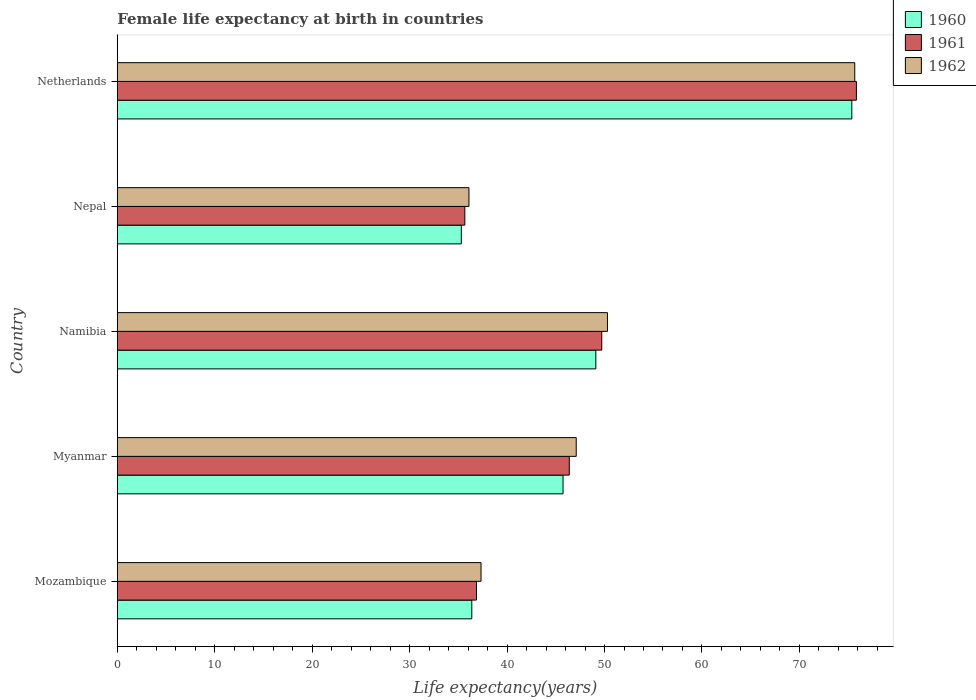How many different coloured bars are there?
Keep it short and to the point. 3. Are the number of bars per tick equal to the number of legend labels?
Keep it short and to the point. Yes. Are the number of bars on each tick of the Y-axis equal?
Give a very brief answer. Yes. How many bars are there on the 5th tick from the top?
Provide a succinct answer. 3. What is the female life expectancy at birth in 1962 in Myanmar?
Your answer should be very brief. 47.1. Across all countries, what is the maximum female life expectancy at birth in 1962?
Give a very brief answer. 75.68. Across all countries, what is the minimum female life expectancy at birth in 1961?
Provide a short and direct response. 35.67. In which country was the female life expectancy at birth in 1960 minimum?
Make the answer very short. Nepal. What is the total female life expectancy at birth in 1962 in the graph?
Your answer should be very brief. 246.5. What is the difference between the female life expectancy at birth in 1962 in Myanmar and that in Nepal?
Make the answer very short. 11.01. What is the difference between the female life expectancy at birth in 1962 in Namibia and the female life expectancy at birth in 1961 in Nepal?
Your response must be concise. 14.64. What is the average female life expectancy at birth in 1960 per country?
Give a very brief answer. 48.38. What is the difference between the female life expectancy at birth in 1961 and female life expectancy at birth in 1962 in Nepal?
Make the answer very short. -0.42. What is the ratio of the female life expectancy at birth in 1962 in Nepal to that in Netherlands?
Provide a short and direct response. 0.48. What is the difference between the highest and the second highest female life expectancy at birth in 1961?
Your response must be concise. 26.13. What is the difference between the highest and the lowest female life expectancy at birth in 1962?
Your answer should be very brief. 39.59. Is the sum of the female life expectancy at birth in 1960 in Myanmar and Nepal greater than the maximum female life expectancy at birth in 1961 across all countries?
Provide a succinct answer. Yes. How many bars are there?
Your answer should be compact. 15. Does the graph contain grids?
Offer a terse response. No. Where does the legend appear in the graph?
Give a very brief answer. Top right. What is the title of the graph?
Provide a succinct answer. Female life expectancy at birth in countries. What is the label or title of the X-axis?
Provide a short and direct response. Life expectancy(years). What is the label or title of the Y-axis?
Provide a succinct answer. Country. What is the Life expectancy(years) in 1960 in Mozambique?
Provide a short and direct response. 36.38. What is the Life expectancy(years) of 1961 in Mozambique?
Ensure brevity in your answer.  36.86. What is the Life expectancy(years) in 1962 in Mozambique?
Your answer should be compact. 37.33. What is the Life expectancy(years) in 1960 in Myanmar?
Ensure brevity in your answer.  45.74. What is the Life expectancy(years) in 1961 in Myanmar?
Keep it short and to the point. 46.38. What is the Life expectancy(years) of 1962 in Myanmar?
Offer a very short reply. 47.1. What is the Life expectancy(years) in 1960 in Namibia?
Offer a very short reply. 49.11. What is the Life expectancy(years) in 1961 in Namibia?
Your response must be concise. 49.72. What is the Life expectancy(years) of 1962 in Namibia?
Offer a very short reply. 50.3. What is the Life expectancy(years) in 1960 in Nepal?
Your answer should be very brief. 35.3. What is the Life expectancy(years) of 1961 in Nepal?
Your response must be concise. 35.67. What is the Life expectancy(years) in 1962 in Nepal?
Offer a very short reply. 36.09. What is the Life expectancy(years) of 1960 in Netherlands?
Make the answer very short. 75.38. What is the Life expectancy(years) in 1961 in Netherlands?
Provide a succinct answer. 75.85. What is the Life expectancy(years) in 1962 in Netherlands?
Offer a terse response. 75.68. Across all countries, what is the maximum Life expectancy(years) of 1960?
Your answer should be compact. 75.38. Across all countries, what is the maximum Life expectancy(years) in 1961?
Ensure brevity in your answer.  75.85. Across all countries, what is the maximum Life expectancy(years) in 1962?
Give a very brief answer. 75.68. Across all countries, what is the minimum Life expectancy(years) of 1960?
Provide a short and direct response. 35.3. Across all countries, what is the minimum Life expectancy(years) in 1961?
Make the answer very short. 35.67. Across all countries, what is the minimum Life expectancy(years) of 1962?
Offer a very short reply. 36.09. What is the total Life expectancy(years) of 1960 in the graph?
Offer a terse response. 241.92. What is the total Life expectancy(years) of 1961 in the graph?
Provide a short and direct response. 244.48. What is the total Life expectancy(years) of 1962 in the graph?
Keep it short and to the point. 246.5. What is the difference between the Life expectancy(years) of 1960 in Mozambique and that in Myanmar?
Offer a terse response. -9.36. What is the difference between the Life expectancy(years) of 1961 in Mozambique and that in Myanmar?
Your answer should be very brief. -9.52. What is the difference between the Life expectancy(years) of 1962 in Mozambique and that in Myanmar?
Provide a short and direct response. -9.77. What is the difference between the Life expectancy(years) in 1960 in Mozambique and that in Namibia?
Your answer should be very brief. -12.73. What is the difference between the Life expectancy(years) of 1961 in Mozambique and that in Namibia?
Offer a very short reply. -12.85. What is the difference between the Life expectancy(years) of 1962 in Mozambique and that in Namibia?
Your answer should be compact. -12.97. What is the difference between the Life expectancy(years) in 1960 in Mozambique and that in Nepal?
Your response must be concise. 1.08. What is the difference between the Life expectancy(years) in 1961 in Mozambique and that in Nepal?
Ensure brevity in your answer.  1.2. What is the difference between the Life expectancy(years) in 1962 in Mozambique and that in Nepal?
Provide a short and direct response. 1.24. What is the difference between the Life expectancy(years) in 1960 in Mozambique and that in Netherlands?
Make the answer very short. -39. What is the difference between the Life expectancy(years) in 1961 in Mozambique and that in Netherlands?
Offer a terse response. -38.99. What is the difference between the Life expectancy(years) of 1962 in Mozambique and that in Netherlands?
Your answer should be compact. -38.35. What is the difference between the Life expectancy(years) in 1960 in Myanmar and that in Namibia?
Ensure brevity in your answer.  -3.37. What is the difference between the Life expectancy(years) of 1961 in Myanmar and that in Namibia?
Offer a very short reply. -3.33. What is the difference between the Life expectancy(years) of 1962 in Myanmar and that in Namibia?
Offer a terse response. -3.21. What is the difference between the Life expectancy(years) of 1960 in Myanmar and that in Nepal?
Give a very brief answer. 10.44. What is the difference between the Life expectancy(years) in 1961 in Myanmar and that in Nepal?
Your response must be concise. 10.72. What is the difference between the Life expectancy(years) in 1962 in Myanmar and that in Nepal?
Keep it short and to the point. 11.01. What is the difference between the Life expectancy(years) of 1960 in Myanmar and that in Netherlands?
Your answer should be compact. -29.64. What is the difference between the Life expectancy(years) in 1961 in Myanmar and that in Netherlands?
Your answer should be compact. -29.47. What is the difference between the Life expectancy(years) in 1962 in Myanmar and that in Netherlands?
Keep it short and to the point. -28.58. What is the difference between the Life expectancy(years) of 1960 in Namibia and that in Nepal?
Make the answer very short. 13.81. What is the difference between the Life expectancy(years) in 1961 in Namibia and that in Nepal?
Give a very brief answer. 14.05. What is the difference between the Life expectancy(years) of 1962 in Namibia and that in Nepal?
Provide a short and direct response. 14.21. What is the difference between the Life expectancy(years) of 1960 in Namibia and that in Netherlands?
Give a very brief answer. -26.27. What is the difference between the Life expectancy(years) in 1961 in Namibia and that in Netherlands?
Offer a terse response. -26.13. What is the difference between the Life expectancy(years) in 1962 in Namibia and that in Netherlands?
Give a very brief answer. -25.38. What is the difference between the Life expectancy(years) of 1960 in Nepal and that in Netherlands?
Keep it short and to the point. -40.08. What is the difference between the Life expectancy(years) in 1961 in Nepal and that in Netherlands?
Your answer should be very brief. -40.18. What is the difference between the Life expectancy(years) of 1962 in Nepal and that in Netherlands?
Offer a terse response. -39.59. What is the difference between the Life expectancy(years) in 1960 in Mozambique and the Life expectancy(years) in 1961 in Myanmar?
Offer a very short reply. -10. What is the difference between the Life expectancy(years) in 1960 in Mozambique and the Life expectancy(years) in 1962 in Myanmar?
Offer a very short reply. -10.72. What is the difference between the Life expectancy(years) of 1961 in Mozambique and the Life expectancy(years) of 1962 in Myanmar?
Your answer should be very brief. -10.23. What is the difference between the Life expectancy(years) in 1960 in Mozambique and the Life expectancy(years) in 1961 in Namibia?
Offer a terse response. -13.34. What is the difference between the Life expectancy(years) in 1960 in Mozambique and the Life expectancy(years) in 1962 in Namibia?
Offer a terse response. -13.92. What is the difference between the Life expectancy(years) of 1961 in Mozambique and the Life expectancy(years) of 1962 in Namibia?
Make the answer very short. -13.44. What is the difference between the Life expectancy(years) in 1960 in Mozambique and the Life expectancy(years) in 1961 in Nepal?
Offer a terse response. 0.71. What is the difference between the Life expectancy(years) of 1960 in Mozambique and the Life expectancy(years) of 1962 in Nepal?
Provide a short and direct response. 0.29. What is the difference between the Life expectancy(years) of 1961 in Mozambique and the Life expectancy(years) of 1962 in Nepal?
Your answer should be compact. 0.78. What is the difference between the Life expectancy(years) of 1960 in Mozambique and the Life expectancy(years) of 1961 in Netherlands?
Your answer should be very brief. -39.47. What is the difference between the Life expectancy(years) in 1960 in Mozambique and the Life expectancy(years) in 1962 in Netherlands?
Offer a terse response. -39.3. What is the difference between the Life expectancy(years) of 1961 in Mozambique and the Life expectancy(years) of 1962 in Netherlands?
Give a very brief answer. -38.82. What is the difference between the Life expectancy(years) in 1960 in Myanmar and the Life expectancy(years) in 1961 in Namibia?
Give a very brief answer. -3.97. What is the difference between the Life expectancy(years) of 1960 in Myanmar and the Life expectancy(years) of 1962 in Namibia?
Ensure brevity in your answer.  -4.56. What is the difference between the Life expectancy(years) of 1961 in Myanmar and the Life expectancy(years) of 1962 in Namibia?
Offer a very short reply. -3.92. What is the difference between the Life expectancy(years) of 1960 in Myanmar and the Life expectancy(years) of 1961 in Nepal?
Your answer should be very brief. 10.08. What is the difference between the Life expectancy(years) in 1960 in Myanmar and the Life expectancy(years) in 1962 in Nepal?
Offer a very short reply. 9.66. What is the difference between the Life expectancy(years) of 1961 in Myanmar and the Life expectancy(years) of 1962 in Nepal?
Ensure brevity in your answer.  10.3. What is the difference between the Life expectancy(years) in 1960 in Myanmar and the Life expectancy(years) in 1961 in Netherlands?
Provide a succinct answer. -30.11. What is the difference between the Life expectancy(years) in 1960 in Myanmar and the Life expectancy(years) in 1962 in Netherlands?
Your response must be concise. -29.94. What is the difference between the Life expectancy(years) in 1961 in Myanmar and the Life expectancy(years) in 1962 in Netherlands?
Your answer should be very brief. -29.3. What is the difference between the Life expectancy(years) in 1960 in Namibia and the Life expectancy(years) in 1961 in Nepal?
Keep it short and to the point. 13.45. What is the difference between the Life expectancy(years) in 1960 in Namibia and the Life expectancy(years) in 1962 in Nepal?
Keep it short and to the point. 13.02. What is the difference between the Life expectancy(years) in 1961 in Namibia and the Life expectancy(years) in 1962 in Nepal?
Make the answer very short. 13.63. What is the difference between the Life expectancy(years) in 1960 in Namibia and the Life expectancy(years) in 1961 in Netherlands?
Provide a succinct answer. -26.74. What is the difference between the Life expectancy(years) in 1960 in Namibia and the Life expectancy(years) in 1962 in Netherlands?
Provide a short and direct response. -26.57. What is the difference between the Life expectancy(years) in 1961 in Namibia and the Life expectancy(years) in 1962 in Netherlands?
Make the answer very short. -25.96. What is the difference between the Life expectancy(years) in 1960 in Nepal and the Life expectancy(years) in 1961 in Netherlands?
Your answer should be very brief. -40.55. What is the difference between the Life expectancy(years) in 1960 in Nepal and the Life expectancy(years) in 1962 in Netherlands?
Keep it short and to the point. -40.38. What is the difference between the Life expectancy(years) of 1961 in Nepal and the Life expectancy(years) of 1962 in Netherlands?
Offer a terse response. -40.01. What is the average Life expectancy(years) of 1960 per country?
Give a very brief answer. 48.38. What is the average Life expectancy(years) in 1961 per country?
Give a very brief answer. 48.9. What is the average Life expectancy(years) in 1962 per country?
Provide a short and direct response. 49.3. What is the difference between the Life expectancy(years) of 1960 and Life expectancy(years) of 1961 in Mozambique?
Ensure brevity in your answer.  -0.48. What is the difference between the Life expectancy(years) of 1960 and Life expectancy(years) of 1962 in Mozambique?
Offer a very short reply. -0.95. What is the difference between the Life expectancy(years) of 1961 and Life expectancy(years) of 1962 in Mozambique?
Your response must be concise. -0.47. What is the difference between the Life expectancy(years) of 1960 and Life expectancy(years) of 1961 in Myanmar?
Keep it short and to the point. -0.64. What is the difference between the Life expectancy(years) in 1960 and Life expectancy(years) in 1962 in Myanmar?
Your answer should be very brief. -1.35. What is the difference between the Life expectancy(years) of 1961 and Life expectancy(years) of 1962 in Myanmar?
Make the answer very short. -0.71. What is the difference between the Life expectancy(years) of 1960 and Life expectancy(years) of 1961 in Namibia?
Give a very brief answer. -0.61. What is the difference between the Life expectancy(years) of 1960 and Life expectancy(years) of 1962 in Namibia?
Provide a succinct answer. -1.19. What is the difference between the Life expectancy(years) of 1961 and Life expectancy(years) of 1962 in Namibia?
Ensure brevity in your answer.  -0.58. What is the difference between the Life expectancy(years) in 1960 and Life expectancy(years) in 1961 in Nepal?
Offer a very short reply. -0.36. What is the difference between the Life expectancy(years) of 1960 and Life expectancy(years) of 1962 in Nepal?
Keep it short and to the point. -0.78. What is the difference between the Life expectancy(years) of 1961 and Life expectancy(years) of 1962 in Nepal?
Offer a terse response. -0.42. What is the difference between the Life expectancy(years) in 1960 and Life expectancy(years) in 1961 in Netherlands?
Make the answer very short. -0.47. What is the difference between the Life expectancy(years) in 1960 and Life expectancy(years) in 1962 in Netherlands?
Your answer should be very brief. -0.3. What is the difference between the Life expectancy(years) of 1961 and Life expectancy(years) of 1962 in Netherlands?
Provide a short and direct response. 0.17. What is the ratio of the Life expectancy(years) in 1960 in Mozambique to that in Myanmar?
Give a very brief answer. 0.8. What is the ratio of the Life expectancy(years) in 1961 in Mozambique to that in Myanmar?
Provide a succinct answer. 0.79. What is the ratio of the Life expectancy(years) in 1962 in Mozambique to that in Myanmar?
Offer a terse response. 0.79. What is the ratio of the Life expectancy(years) in 1960 in Mozambique to that in Namibia?
Your answer should be compact. 0.74. What is the ratio of the Life expectancy(years) in 1961 in Mozambique to that in Namibia?
Your answer should be compact. 0.74. What is the ratio of the Life expectancy(years) in 1962 in Mozambique to that in Namibia?
Provide a short and direct response. 0.74. What is the ratio of the Life expectancy(years) of 1960 in Mozambique to that in Nepal?
Provide a succinct answer. 1.03. What is the ratio of the Life expectancy(years) of 1961 in Mozambique to that in Nepal?
Your answer should be very brief. 1.03. What is the ratio of the Life expectancy(years) in 1962 in Mozambique to that in Nepal?
Provide a succinct answer. 1.03. What is the ratio of the Life expectancy(years) of 1960 in Mozambique to that in Netherlands?
Make the answer very short. 0.48. What is the ratio of the Life expectancy(years) in 1961 in Mozambique to that in Netherlands?
Make the answer very short. 0.49. What is the ratio of the Life expectancy(years) in 1962 in Mozambique to that in Netherlands?
Offer a terse response. 0.49. What is the ratio of the Life expectancy(years) in 1960 in Myanmar to that in Namibia?
Make the answer very short. 0.93. What is the ratio of the Life expectancy(years) in 1961 in Myanmar to that in Namibia?
Provide a succinct answer. 0.93. What is the ratio of the Life expectancy(years) of 1962 in Myanmar to that in Namibia?
Your answer should be compact. 0.94. What is the ratio of the Life expectancy(years) in 1960 in Myanmar to that in Nepal?
Offer a very short reply. 1.3. What is the ratio of the Life expectancy(years) of 1961 in Myanmar to that in Nepal?
Your response must be concise. 1.3. What is the ratio of the Life expectancy(years) in 1962 in Myanmar to that in Nepal?
Give a very brief answer. 1.31. What is the ratio of the Life expectancy(years) in 1960 in Myanmar to that in Netherlands?
Your response must be concise. 0.61. What is the ratio of the Life expectancy(years) of 1961 in Myanmar to that in Netherlands?
Offer a very short reply. 0.61. What is the ratio of the Life expectancy(years) of 1962 in Myanmar to that in Netherlands?
Your answer should be very brief. 0.62. What is the ratio of the Life expectancy(years) in 1960 in Namibia to that in Nepal?
Offer a very short reply. 1.39. What is the ratio of the Life expectancy(years) in 1961 in Namibia to that in Nepal?
Provide a succinct answer. 1.39. What is the ratio of the Life expectancy(years) in 1962 in Namibia to that in Nepal?
Make the answer very short. 1.39. What is the ratio of the Life expectancy(years) of 1960 in Namibia to that in Netherlands?
Provide a succinct answer. 0.65. What is the ratio of the Life expectancy(years) of 1961 in Namibia to that in Netherlands?
Provide a short and direct response. 0.66. What is the ratio of the Life expectancy(years) of 1962 in Namibia to that in Netherlands?
Offer a very short reply. 0.66. What is the ratio of the Life expectancy(years) of 1960 in Nepal to that in Netherlands?
Make the answer very short. 0.47. What is the ratio of the Life expectancy(years) of 1961 in Nepal to that in Netherlands?
Your answer should be very brief. 0.47. What is the ratio of the Life expectancy(years) of 1962 in Nepal to that in Netherlands?
Your answer should be compact. 0.48. What is the difference between the highest and the second highest Life expectancy(years) in 1960?
Provide a succinct answer. 26.27. What is the difference between the highest and the second highest Life expectancy(years) of 1961?
Give a very brief answer. 26.13. What is the difference between the highest and the second highest Life expectancy(years) of 1962?
Ensure brevity in your answer.  25.38. What is the difference between the highest and the lowest Life expectancy(years) of 1960?
Provide a succinct answer. 40.08. What is the difference between the highest and the lowest Life expectancy(years) of 1961?
Your response must be concise. 40.18. What is the difference between the highest and the lowest Life expectancy(years) of 1962?
Keep it short and to the point. 39.59. 